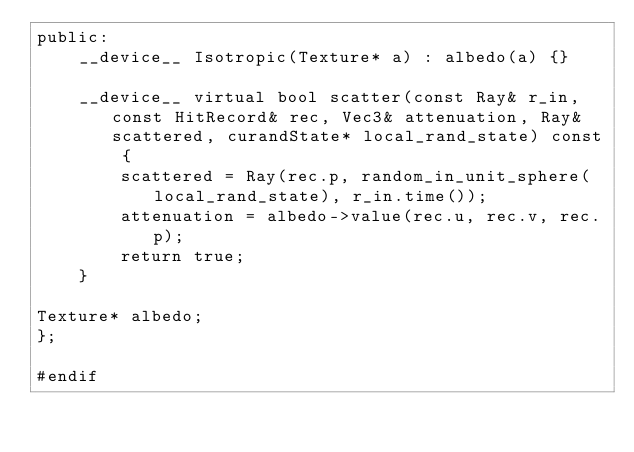Convert code to text. <code><loc_0><loc_0><loc_500><loc_500><_Cuda_>public:
    __device__ Isotropic(Texture* a) : albedo(a) {}

    __device__ virtual bool scatter(const Ray& r_in, const HitRecord& rec, Vec3& attenuation, Ray& scattered, curandState* local_rand_state) const {
        scattered = Ray(rec.p, random_in_unit_sphere(local_rand_state), r_in.time());
        attenuation = albedo->value(rec.u, rec.v, rec.p);
        return true;
    }

Texture* albedo;
};

#endif</code> 